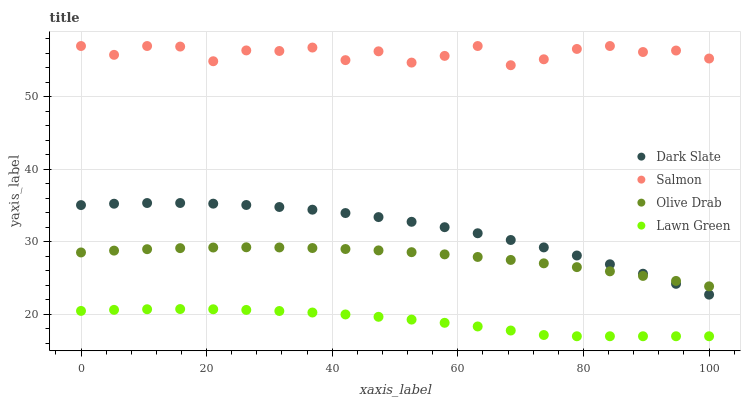Does Lawn Green have the minimum area under the curve?
Answer yes or no. Yes. Does Salmon have the maximum area under the curve?
Answer yes or no. Yes. Does Olive Drab have the minimum area under the curve?
Answer yes or no. No. Does Olive Drab have the maximum area under the curve?
Answer yes or no. No. Is Olive Drab the smoothest?
Answer yes or no. Yes. Is Salmon the roughest?
Answer yes or no. Yes. Is Salmon the smoothest?
Answer yes or no. No. Is Olive Drab the roughest?
Answer yes or no. No. Does Lawn Green have the lowest value?
Answer yes or no. Yes. Does Olive Drab have the lowest value?
Answer yes or no. No. Does Salmon have the highest value?
Answer yes or no. Yes. Does Olive Drab have the highest value?
Answer yes or no. No. Is Dark Slate less than Salmon?
Answer yes or no. Yes. Is Olive Drab greater than Lawn Green?
Answer yes or no. Yes. Does Olive Drab intersect Dark Slate?
Answer yes or no. Yes. Is Olive Drab less than Dark Slate?
Answer yes or no. No. Is Olive Drab greater than Dark Slate?
Answer yes or no. No. Does Dark Slate intersect Salmon?
Answer yes or no. No. 